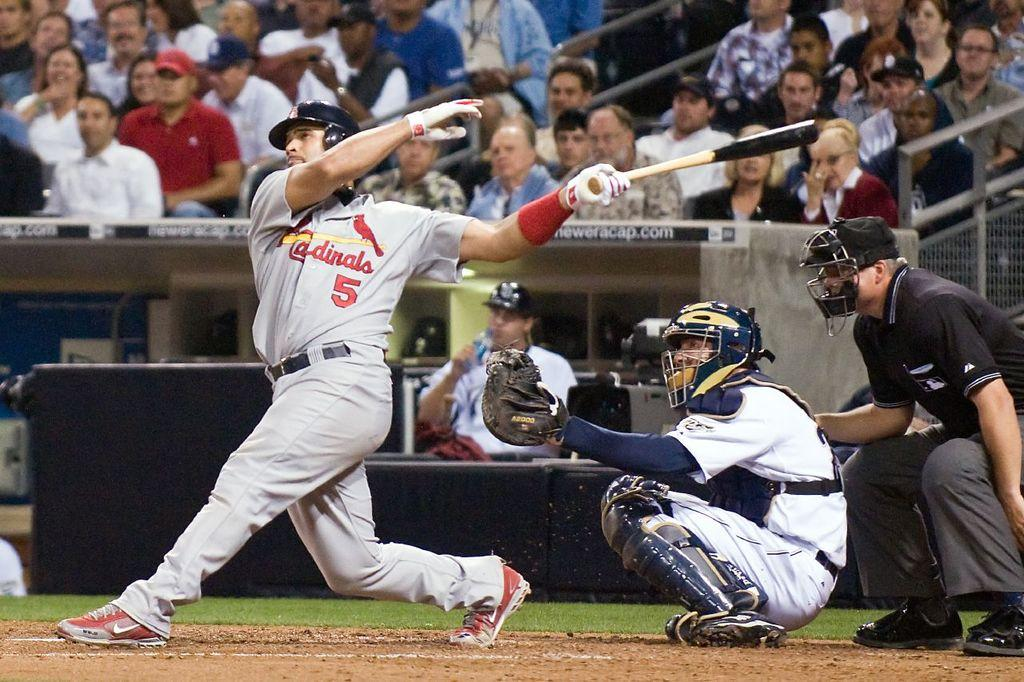Provide a one-sentence caption for the provided image. A baseball player for the Cardinals has swung his bat at the ball. 